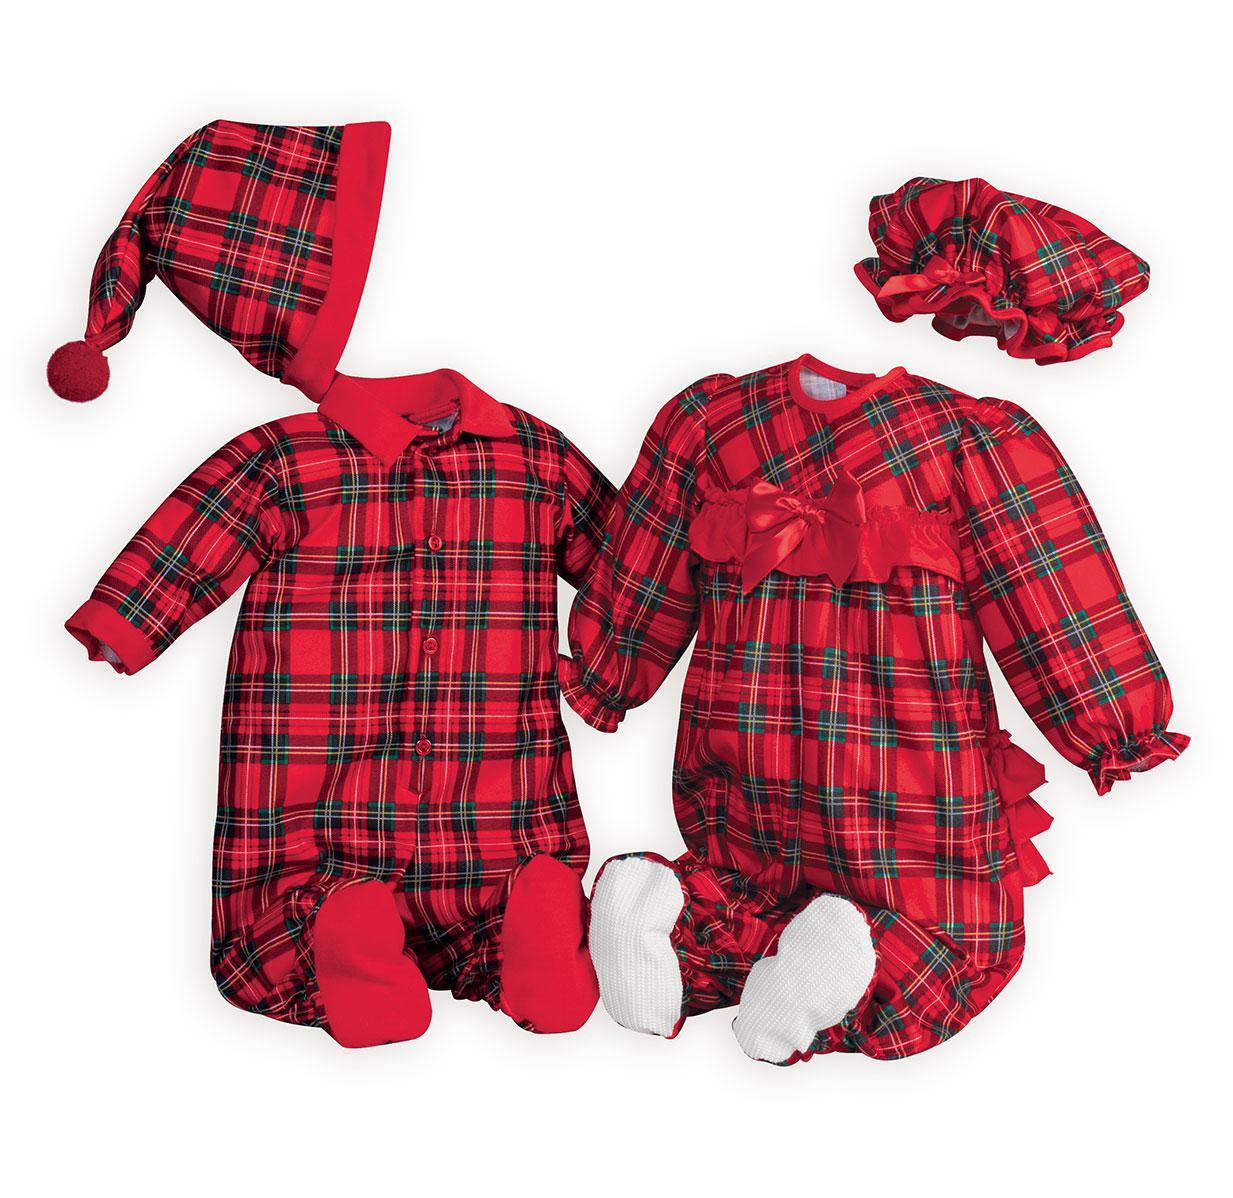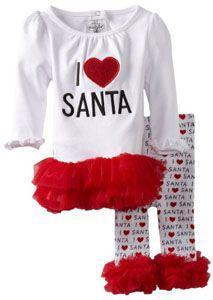The first image is the image on the left, the second image is the image on the right. Assess this claim about the two images: "there are two pair of pajamas per image pair". Correct or not? Answer yes or no. No. The first image is the image on the left, the second image is the image on the right. Given the left and right images, does the statement "In one image there is a pair of pink Christmas children's pajamas in the center of the image." hold true? Answer yes or no. No. 